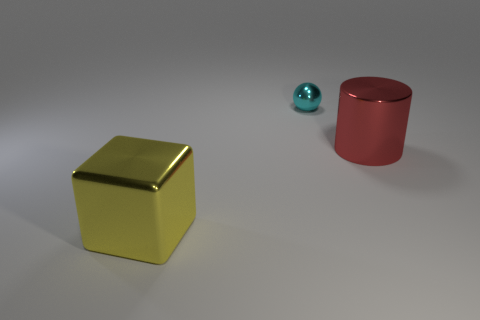Do the big red object and the big object that is on the left side of the red shiny thing have the same material?
Your response must be concise. Yes. What number of other objects are the same shape as the cyan thing?
Offer a very short reply. 0. Are there the same number of large shiny cubes that are to the left of the cyan shiny thing and metallic cubes?
Your answer should be very brief. Yes. Do the large thing that is in front of the cylinder and the metal thing that is to the right of the tiny cyan ball have the same shape?
Offer a terse response. No. Are there fewer small cyan objects that are to the left of the red metallic object than brown rubber blocks?
Provide a succinct answer. No. How big is the yellow object in front of the red metal cylinder?
Your answer should be very brief. Large. What is the shape of the large object in front of the big object that is right of the metal object in front of the big red cylinder?
Your answer should be very brief. Cube. The shiny object that is both on the left side of the shiny cylinder and behind the block has what shape?
Your response must be concise. Sphere. Are there any yellow cubes of the same size as the red cylinder?
Your response must be concise. Yes. Is the shape of the cyan metallic thing the same as the big red thing?
Your answer should be very brief. No. 